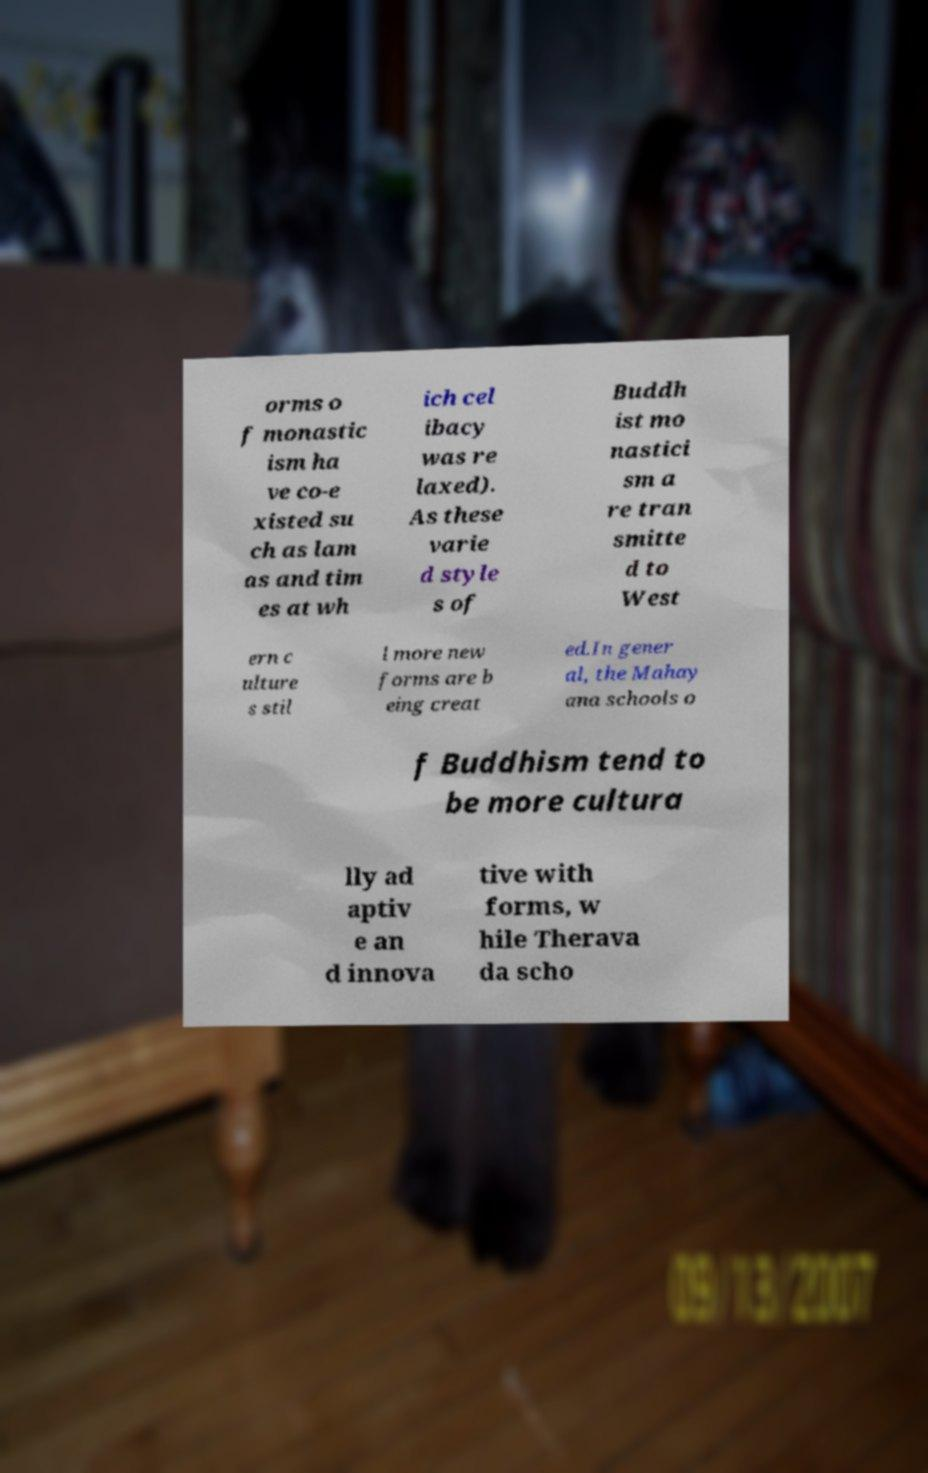Could you extract and type out the text from this image? orms o f monastic ism ha ve co-e xisted su ch as lam as and tim es at wh ich cel ibacy was re laxed). As these varie d style s of Buddh ist mo nastici sm a re tran smitte d to West ern c ulture s stil l more new forms are b eing creat ed.In gener al, the Mahay ana schools o f Buddhism tend to be more cultura lly ad aptiv e an d innova tive with forms, w hile Therava da scho 